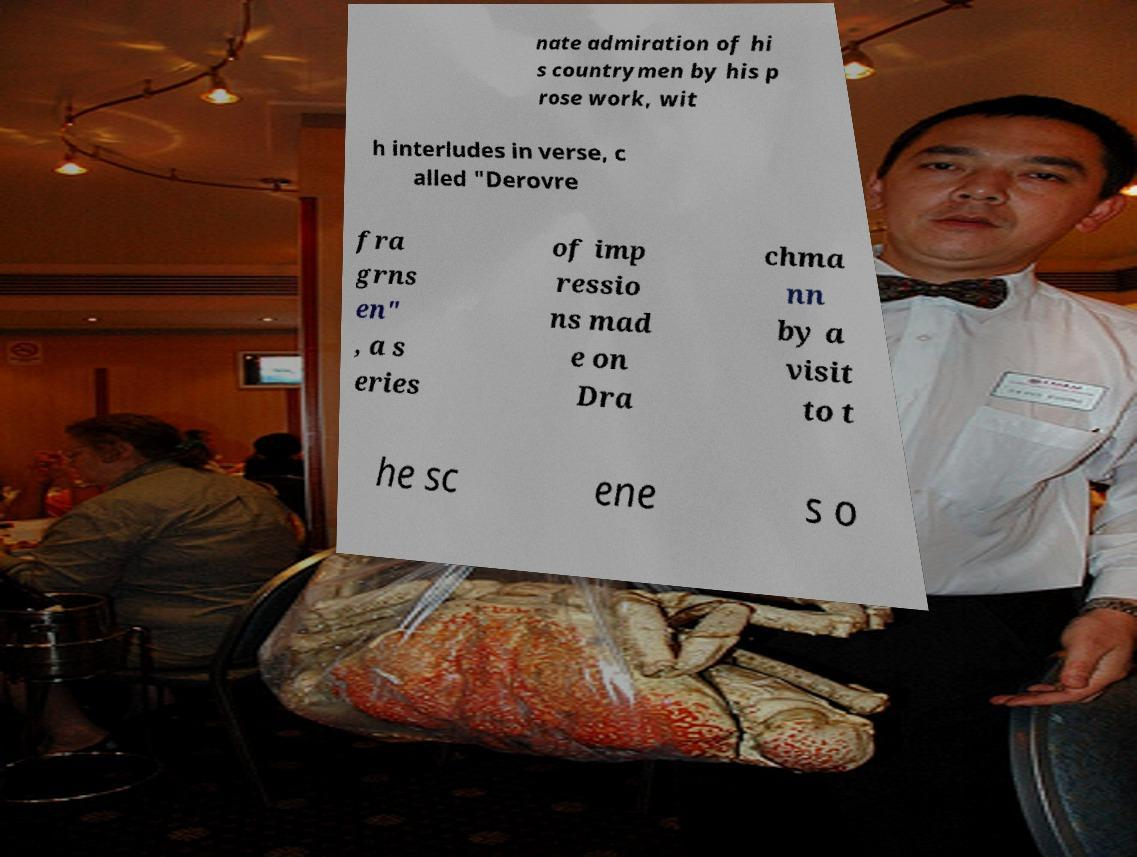There's text embedded in this image that I need extracted. Can you transcribe it verbatim? nate admiration of hi s countrymen by his p rose work, wit h interludes in verse, c alled "Derovre fra grns en" , a s eries of imp ressio ns mad e on Dra chma nn by a visit to t he sc ene s o 